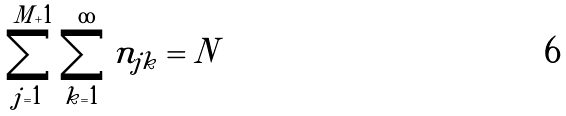<formula> <loc_0><loc_0><loc_500><loc_500>\sum _ { j = 1 } ^ { M + 1 } \sum _ { k = 1 } ^ { \infty } n _ { j k } = N</formula> 